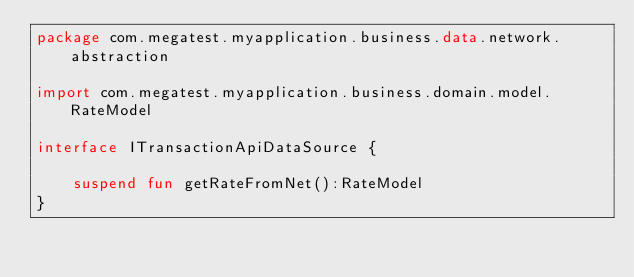Convert code to text. <code><loc_0><loc_0><loc_500><loc_500><_Kotlin_>package com.megatest.myapplication.business.data.network.abstraction

import com.megatest.myapplication.business.domain.model.RateModel

interface ITransactionApiDataSource {

    suspend fun getRateFromNet():RateModel
}</code> 